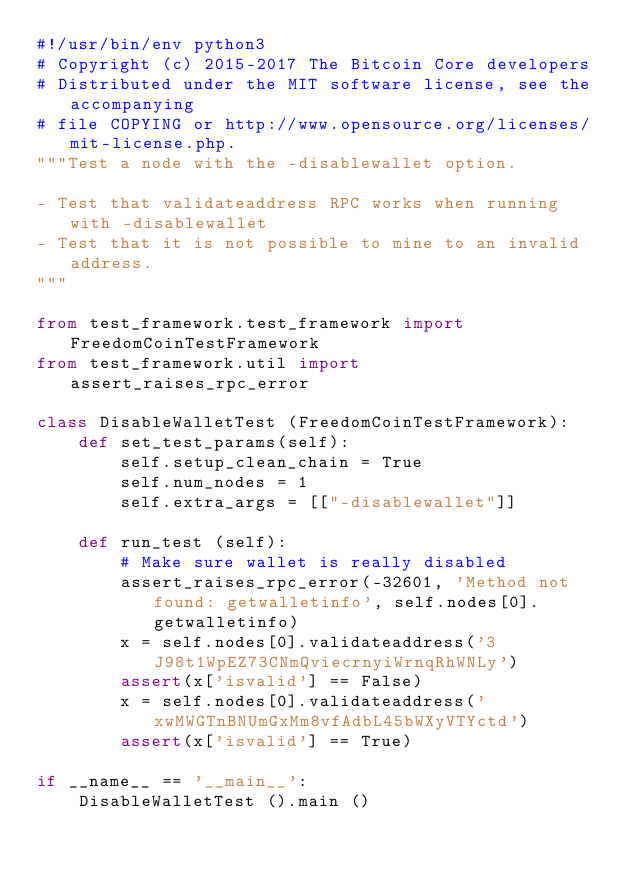Convert code to text. <code><loc_0><loc_0><loc_500><loc_500><_Python_>#!/usr/bin/env python3
# Copyright (c) 2015-2017 The Bitcoin Core developers
# Distributed under the MIT software license, see the accompanying
# file COPYING or http://www.opensource.org/licenses/mit-license.php.
"""Test a node with the -disablewallet option.

- Test that validateaddress RPC works when running with -disablewallet
- Test that it is not possible to mine to an invalid address.
"""

from test_framework.test_framework import FreedomCoinTestFramework
from test_framework.util import assert_raises_rpc_error

class DisableWalletTest (FreedomCoinTestFramework):
    def set_test_params(self):
        self.setup_clean_chain = True
        self.num_nodes = 1
        self.extra_args = [["-disablewallet"]]

    def run_test (self):
        # Make sure wallet is really disabled
        assert_raises_rpc_error(-32601, 'Method not found: getwalletinfo', self.nodes[0].getwalletinfo)
        x = self.nodes[0].validateaddress('3J98t1WpEZ73CNmQviecrnyiWrnqRhWNLy')
        assert(x['isvalid'] == False)
        x = self.nodes[0].validateaddress('xwMWGTnBNUmGxMm8vfAdbL45bWXyVTYctd')
        assert(x['isvalid'] == True)

if __name__ == '__main__':
    DisableWalletTest ().main ()
</code> 